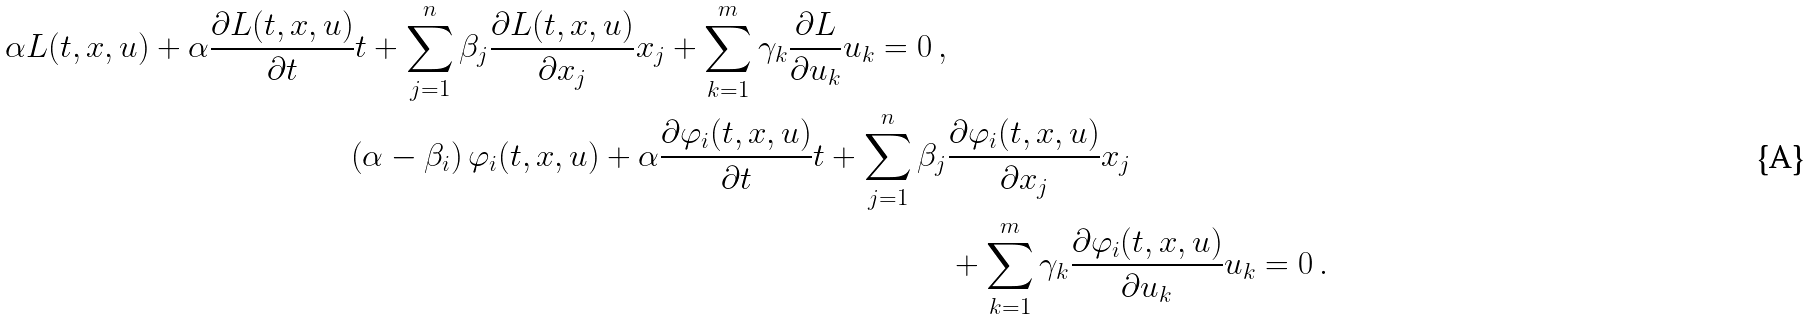<formula> <loc_0><loc_0><loc_500><loc_500>\alpha L ( t , x , u ) + \alpha \frac { \partial L ( t , x , u ) } { \partial t } t + \sum _ { j = 1 } ^ { n } \beta _ { j } \frac { \partial L ( t , x , u ) } { \partial x _ { j } } x _ { j } + \sum _ { k = 1 } ^ { m } \gamma _ { k } \frac { \partial L } { \partial u _ { k } } u _ { k } = 0 \, , \\ \left ( \alpha - \beta _ { i } \right ) \varphi _ { i } ( t , x , u ) + \alpha \frac { \partial \varphi _ { i } ( t , x , u ) } { \partial t } t + \sum _ { j = 1 } ^ { n } \beta _ { j } & \frac { \partial \varphi _ { i } ( t , x , u ) } { \partial x _ { j } } x _ { j } \\ & + \sum _ { k = 1 } ^ { m } \gamma _ { k } \frac { \partial \varphi _ { i } ( t , x , u ) } { \partial u _ { k } } u _ { k } = 0 \, .</formula> 